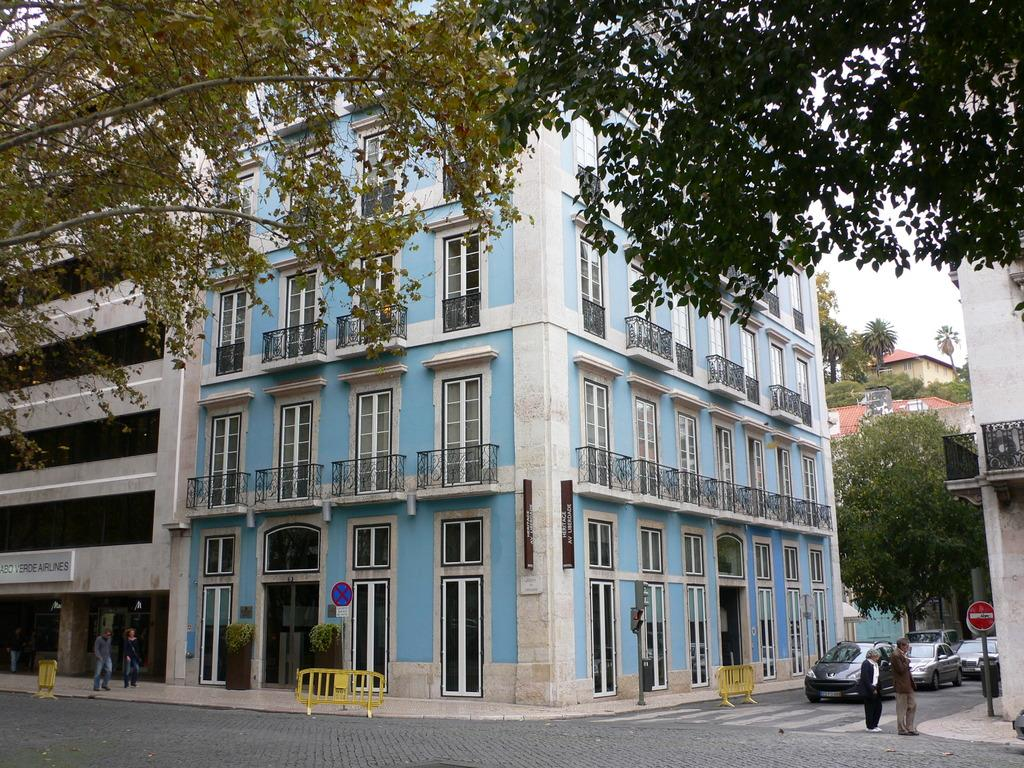What type of structures are visible in the image? There are buildings in the image. What other natural elements can be seen in the image? There are trees in the image. What are the people near the buildings doing? There are people standing near the buildings. What type of transportation is present in the image? There are vehicles in the image. What might be used to control traffic or restrict access in the image? There are barricades on the road. What is visible in the background of the image? The sky is visible in the background of the image. Can you tell me how many giants are holding the barricades in the image? There are no giants present in the image; it features people, buildings, trees, vehicles, and barricades. What type of organization is responsible for the kitten in the image? There is no kitten present in the image. 